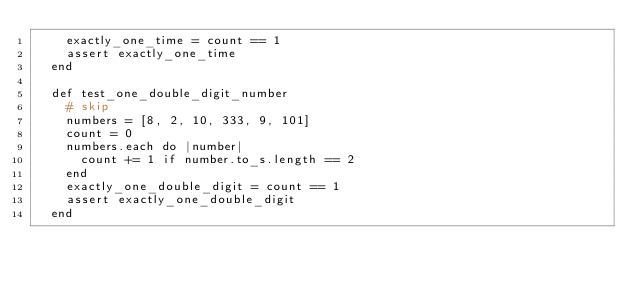Convert code to text. <code><loc_0><loc_0><loc_500><loc_500><_Ruby_>    exactly_one_time = count == 1
    assert exactly_one_time
  end

  def test_one_double_digit_number
    # skip
    numbers = [8, 2, 10, 333, 9, 101]
    count = 0
    numbers.each do |number|
      count += 1 if number.to_s.length == 2
    end
    exactly_one_double_digit = count == 1
    assert exactly_one_double_digit
  end
</code> 